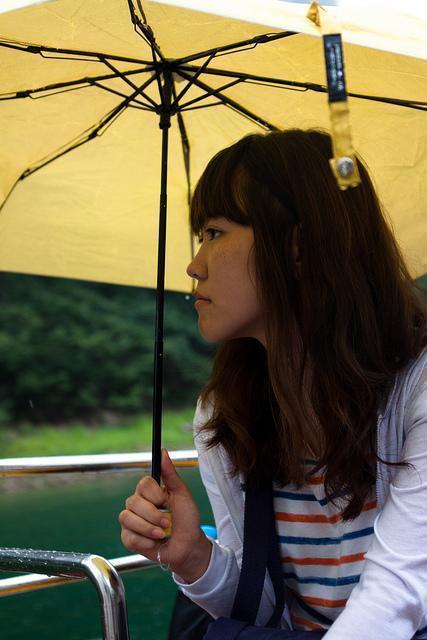When the rain stops how will this umbrella be stored?
Pick the correct solution from the four options below to address the question.
Options: Folded, outside, upside down, vacation rental. Folded. What does this person use the umbrella for?
Make your selection from the four choices given to correctly answer the question.
Options: Snow, hail, sun, rain. Rain. 